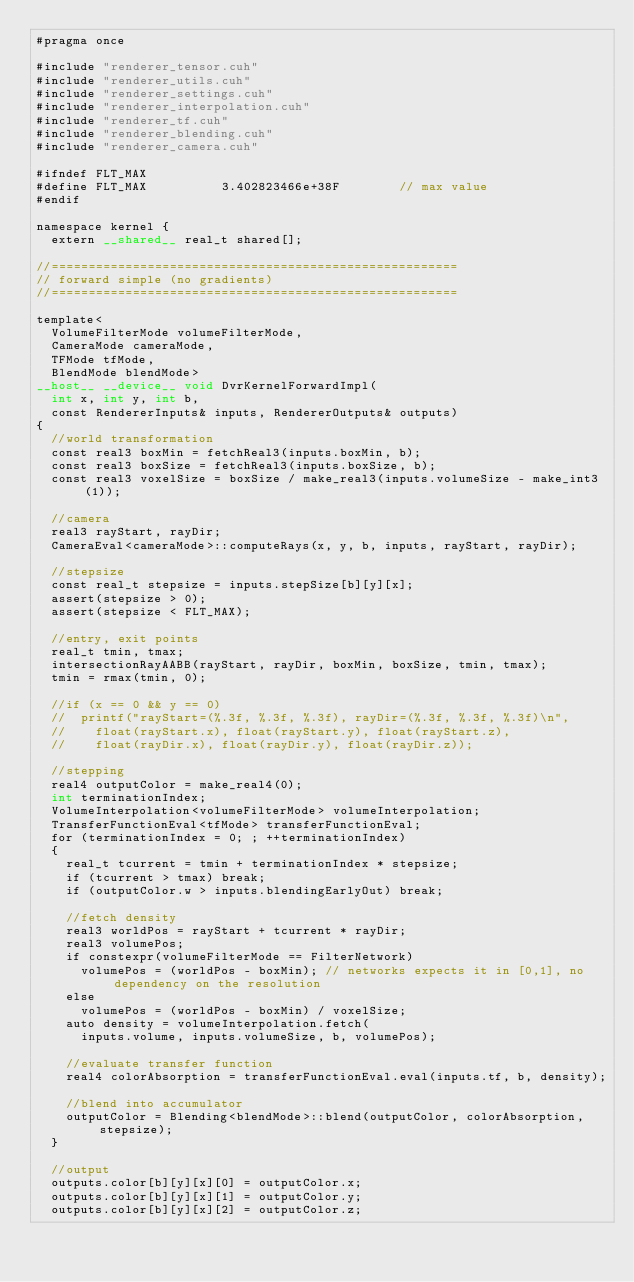Convert code to text. <code><loc_0><loc_0><loc_500><loc_500><_Cuda_>#pragma once

#include "renderer_tensor.cuh"
#include "renderer_utils.cuh"
#include "renderer_settings.cuh"
#include "renderer_interpolation.cuh"
#include "renderer_tf.cuh"
#include "renderer_blending.cuh"
#include "renderer_camera.cuh"

#ifndef FLT_MAX
#define FLT_MAX          3.402823466e+38F        // max value
#endif

namespace kernel {
	extern __shared__ real_t shared[];

//=======================================================
// forward simple (no gradients)
//=======================================================
	
template<
	VolumeFilterMode volumeFilterMode,
	CameraMode cameraMode,
	TFMode tfMode,
	BlendMode blendMode>
__host__ __device__ void DvrKernelForwardImpl(
	int x, int y, int b,
	const RendererInputs& inputs, RendererOutputs& outputs)
{
	//world transformation
	const real3 boxMin = fetchReal3(inputs.boxMin, b);
	const real3 boxSize = fetchReal3(inputs.boxSize, b);
	const real3 voxelSize = boxSize / make_real3(inputs.volumeSize - make_int3(1));

	//camera
	real3 rayStart, rayDir;
	CameraEval<cameraMode>::computeRays(x, y, b, inputs, rayStart, rayDir);

	//stepsize
	const real_t stepsize = inputs.stepSize[b][y][x];
	assert(stepsize > 0);
	assert(stepsize < FLT_MAX);

	//entry, exit points
	real_t tmin, tmax;
	intersectionRayAABB(rayStart, rayDir, boxMin, boxSize, tmin, tmax);
	tmin = rmax(tmin, 0);

	//if (x == 0 && y == 0)
	//	printf("rayStart=(%.3f, %.3f, %.3f), rayDir=(%.3f, %.3f, %.3f)\n",
	//		float(rayStart.x), float(rayStart.y), float(rayStart.z),
	//		float(rayDir.x), float(rayDir.y), float(rayDir.z));
	
	//stepping
	real4 outputColor = make_real4(0);
	int terminationIndex;
	VolumeInterpolation<volumeFilterMode> volumeInterpolation;
	TransferFunctionEval<tfMode> transferFunctionEval;
	for (terminationIndex = 0; ; ++terminationIndex)
	{
		real_t tcurrent = tmin + terminationIndex * stepsize;
		if (tcurrent > tmax) break;
		if (outputColor.w > inputs.blendingEarlyOut) break;
		
		//fetch density
		real3 worldPos = rayStart + tcurrent * rayDir;
		real3 volumePos;
		if constexpr(volumeFilterMode == FilterNetwork)
			volumePos = (worldPos - boxMin); // networks expects it in [0,1], no dependency on the resolution
		else
			volumePos = (worldPos - boxMin) / voxelSize;
		auto density = volumeInterpolation.fetch(
			inputs.volume, inputs.volumeSize, b, volumePos);

		//evaluate transfer function
		real4 colorAbsorption = transferFunctionEval.eval(inputs.tf, b, density);

		//blend into accumulator
		outputColor = Blending<blendMode>::blend(outputColor, colorAbsorption, stepsize);
	}

	//output
	outputs.color[b][y][x][0] = outputColor.x;
	outputs.color[b][y][x][1] = outputColor.y;
	outputs.color[b][y][x][2] = outputColor.z;</code> 